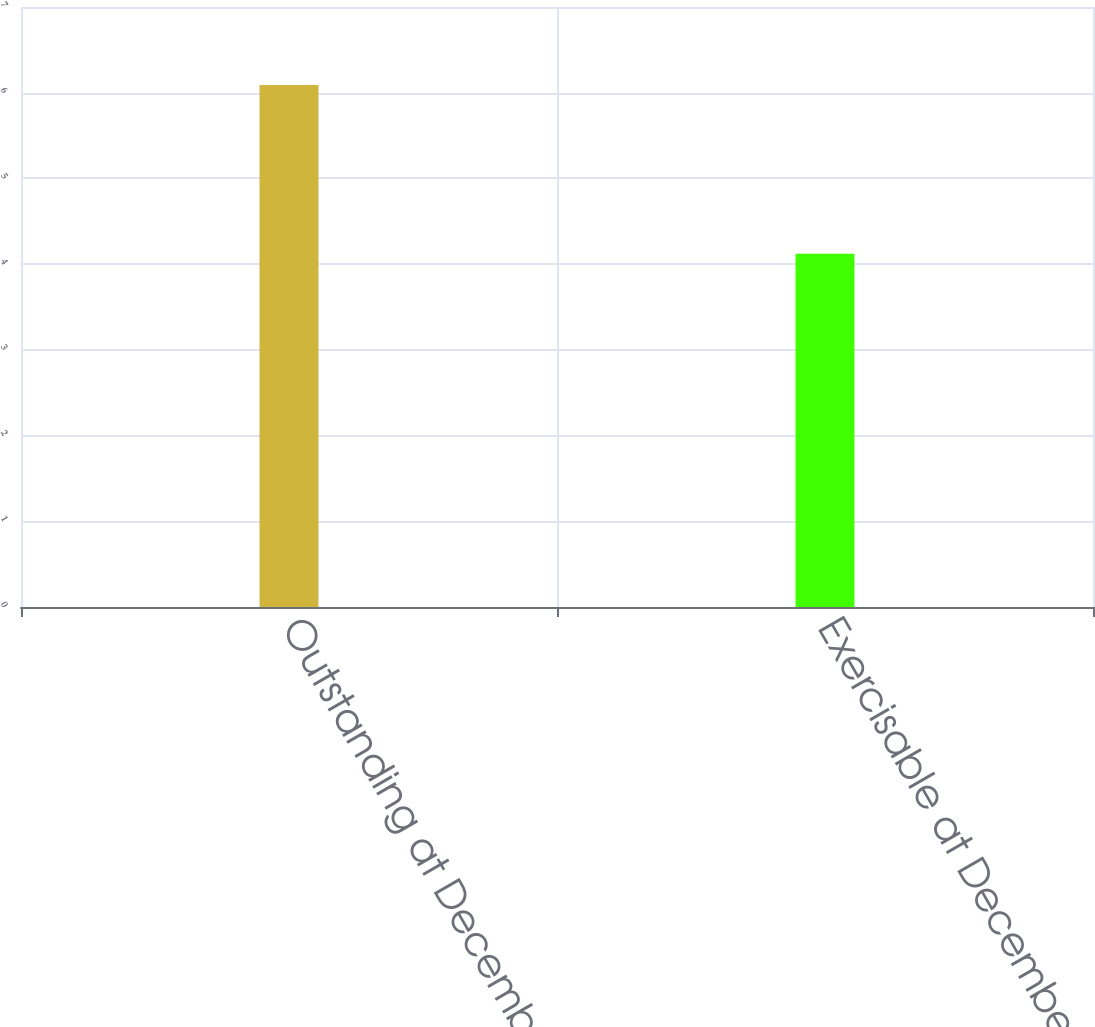Convert chart. <chart><loc_0><loc_0><loc_500><loc_500><bar_chart><fcel>Outstanding at December 31<fcel>Exercisable at December 31<nl><fcel>6.09<fcel>4.12<nl></chart> 